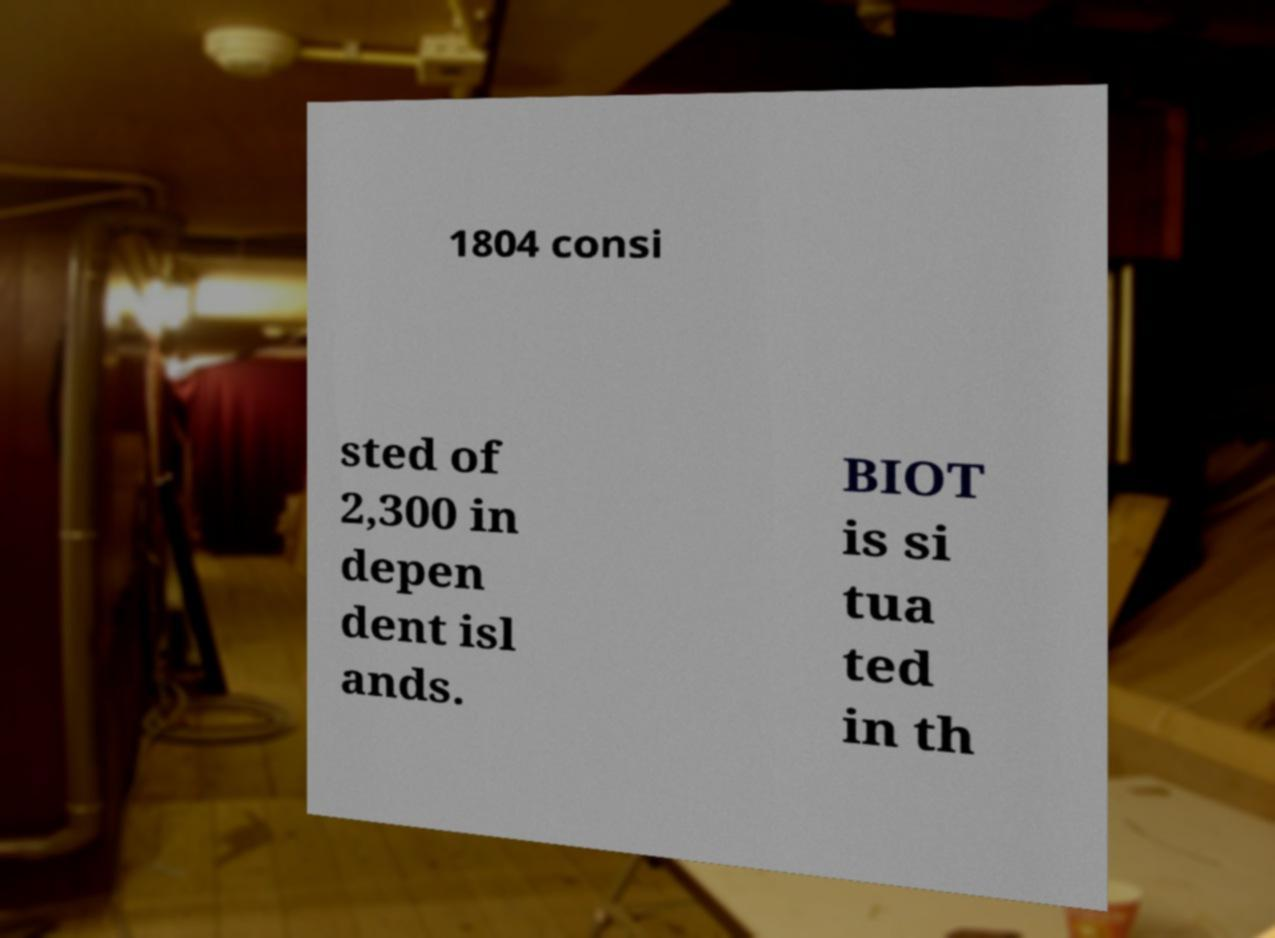Can you accurately transcribe the text from the provided image for me? 1804 consi sted of 2,300 in depen dent isl ands. BIOT is si tua ted in th 